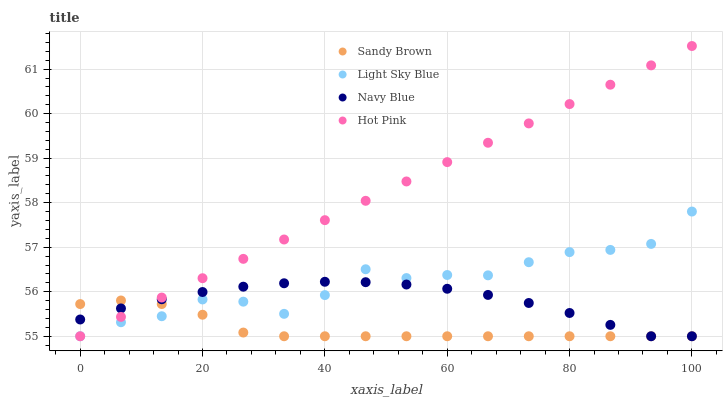Does Sandy Brown have the minimum area under the curve?
Answer yes or no. Yes. Does Hot Pink have the maximum area under the curve?
Answer yes or no. Yes. Does Light Sky Blue have the minimum area under the curve?
Answer yes or no. No. Does Light Sky Blue have the maximum area under the curve?
Answer yes or no. No. Is Hot Pink the smoothest?
Answer yes or no. Yes. Is Light Sky Blue the roughest?
Answer yes or no. Yes. Is Sandy Brown the smoothest?
Answer yes or no. No. Is Sandy Brown the roughest?
Answer yes or no. No. Does Navy Blue have the lowest value?
Answer yes or no. Yes. Does Hot Pink have the highest value?
Answer yes or no. Yes. Does Light Sky Blue have the highest value?
Answer yes or no. No. Does Light Sky Blue intersect Hot Pink?
Answer yes or no. Yes. Is Light Sky Blue less than Hot Pink?
Answer yes or no. No. Is Light Sky Blue greater than Hot Pink?
Answer yes or no. No. 